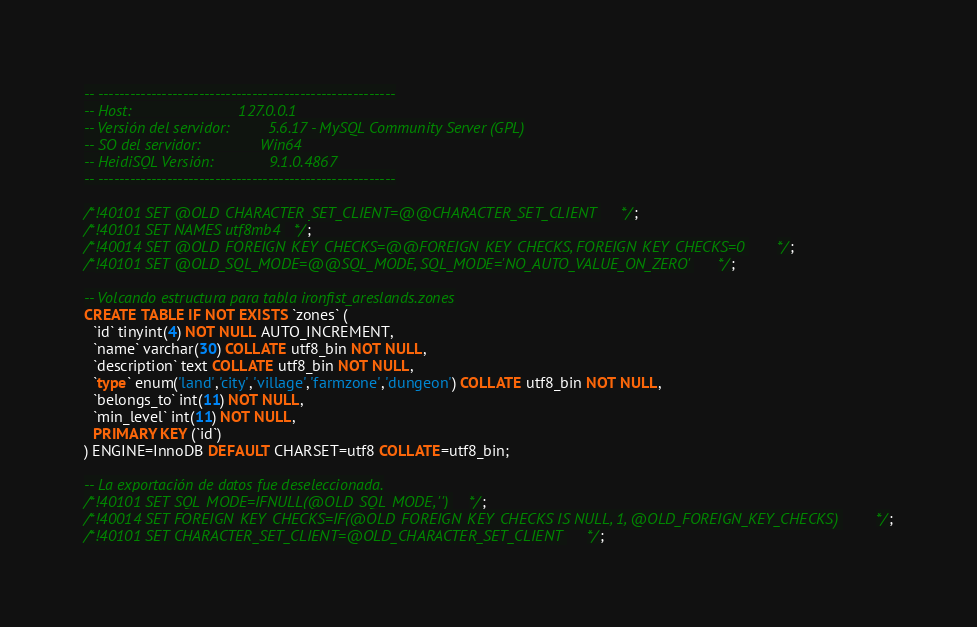<code> <loc_0><loc_0><loc_500><loc_500><_SQL_>-- --------------------------------------------------------
-- Host:                         127.0.0.1
-- Versión del servidor:         5.6.17 - MySQL Community Server (GPL)
-- SO del servidor:              Win64
-- HeidiSQL Versión:             9.1.0.4867
-- --------------------------------------------------------

/*!40101 SET @OLD_CHARACTER_SET_CLIENT=@@CHARACTER_SET_CLIENT */;
/*!40101 SET NAMES utf8mb4 */;
/*!40014 SET @OLD_FOREIGN_KEY_CHECKS=@@FOREIGN_KEY_CHECKS, FOREIGN_KEY_CHECKS=0 */;
/*!40101 SET @OLD_SQL_MODE=@@SQL_MODE, SQL_MODE='NO_AUTO_VALUE_ON_ZERO' */;

-- Volcando estructura para tabla ironfist_areslands.zones
CREATE TABLE IF NOT EXISTS `zones` (
  `id` tinyint(4) NOT NULL AUTO_INCREMENT,
  `name` varchar(30) COLLATE utf8_bin NOT NULL,
  `description` text COLLATE utf8_bin NOT NULL,
  `type` enum('land','city','village','farmzone','dungeon') COLLATE utf8_bin NOT NULL,
  `belongs_to` int(11) NOT NULL,
  `min_level` int(11) NOT NULL,
  PRIMARY KEY (`id`)
) ENGINE=InnoDB DEFAULT CHARSET=utf8 COLLATE=utf8_bin;

-- La exportación de datos fue deseleccionada.
/*!40101 SET SQL_MODE=IFNULL(@OLD_SQL_MODE, '') */;
/*!40014 SET FOREIGN_KEY_CHECKS=IF(@OLD_FOREIGN_KEY_CHECKS IS NULL, 1, @OLD_FOREIGN_KEY_CHECKS) */;
/*!40101 SET CHARACTER_SET_CLIENT=@OLD_CHARACTER_SET_CLIENT */;
</code> 